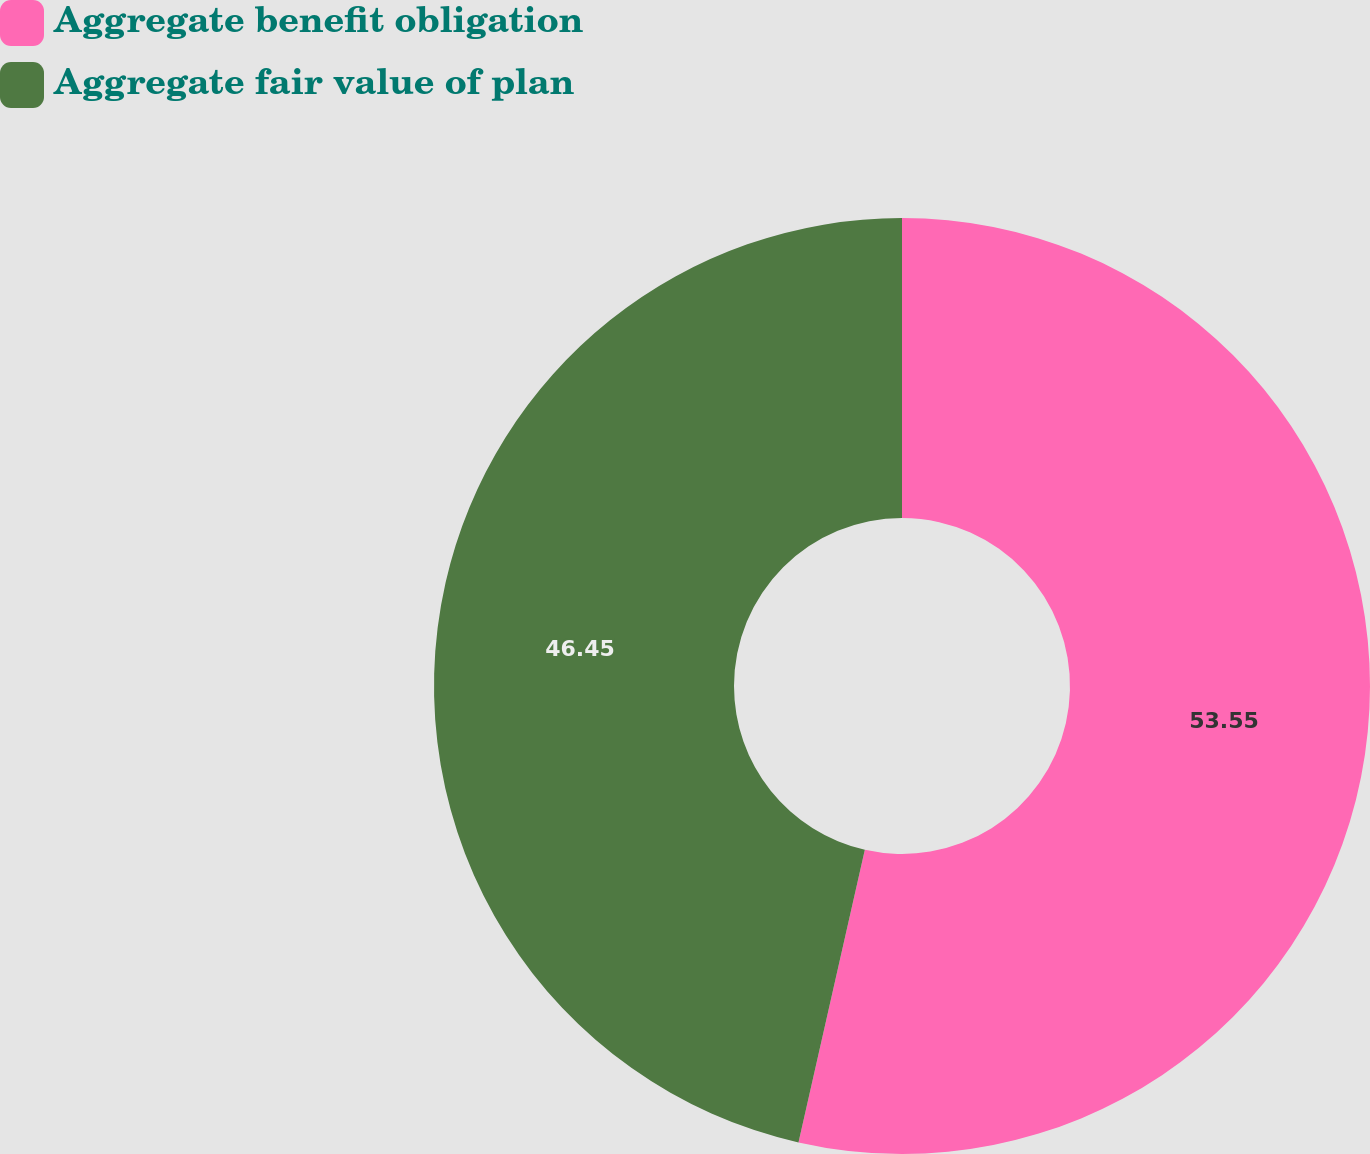Convert chart to OTSL. <chart><loc_0><loc_0><loc_500><loc_500><pie_chart><fcel>Aggregate benefit obligation<fcel>Aggregate fair value of plan<nl><fcel>53.55%<fcel>46.45%<nl></chart> 